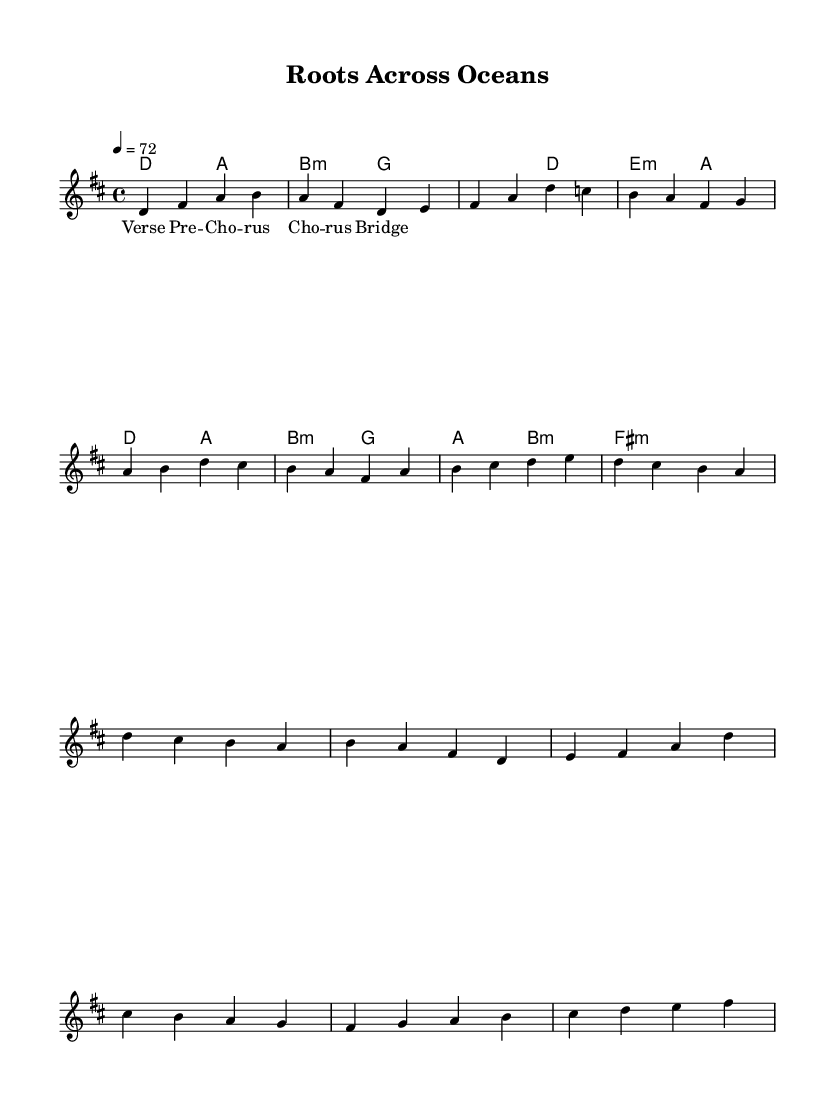What is the key signature of this music? The key signature is indicated right after the clef and shows two sharps, which represent F# and C#. Therefore, the key signature is D major.
Answer: D major What is the time signature of the piece? The time signature appears at the beginning of the score and is represented by the numbers 4/4, which means there are four beats in a measure and the quarter note gets one beat.
Answer: 4/4 What is the tempo marking for this piece? The tempo marking is indicated in beats per minute (BPM) and shows a quarter note equals 72, which means the piece should be played at a speed of 72 beats per minute.
Answer: 72 How many measures are in the verse section? By counting the vertical lines separating the measures in the verse section, there are a total of 4 measures presented in that part.
Answer: 4 What is the first chord in the verse? The first chord is shown above the first measure, which displays the chord letter D, suggesting that the first chord played is a D major chord.
Answer: D Does the piece include a bridge section? The presence of the bridge section is indicated in the sheet music; the bridge has a partial melody and harmonies clearly labeled, confirming that it is a designated section of the composition.
Answer: Yes What is the dominant chord in the chorus? The dominant chord is denoted by the chord label above the measures. In this case, the fifth chord in the key of D major appears as A, which is the dominant chord of D major.
Answer: A 